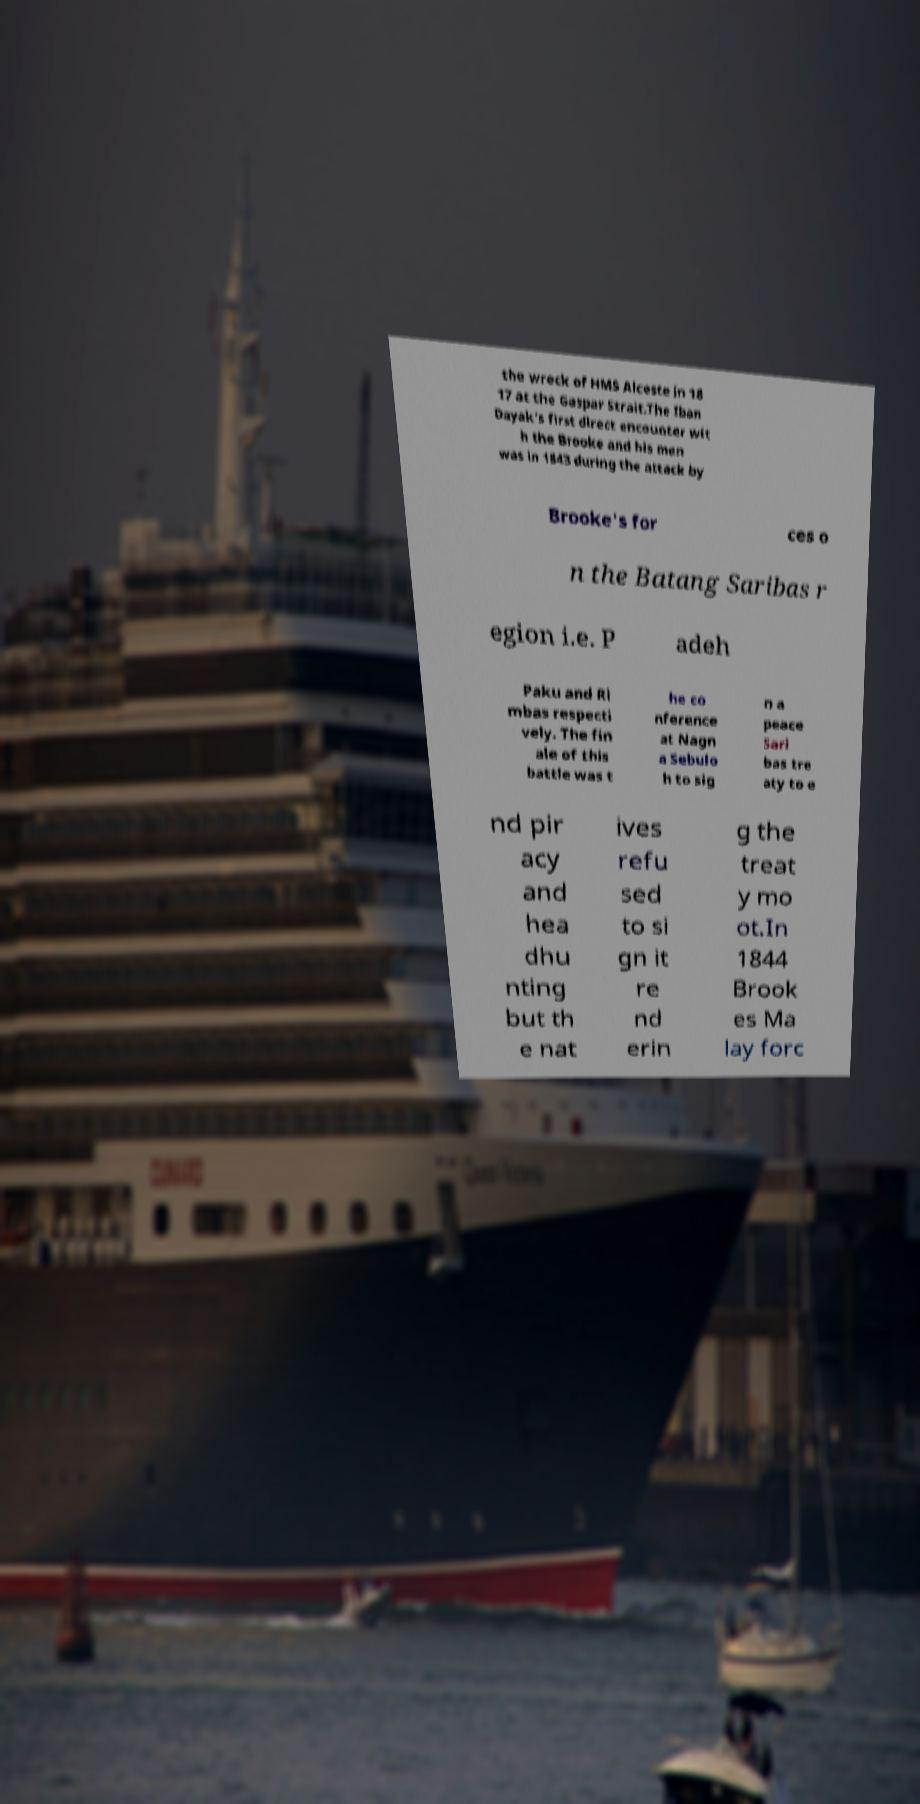Please read and relay the text visible in this image. What does it say? the wreck of HMS Alceste in 18 17 at the Gaspar Strait.The Iban Dayak's first direct encounter wit h the Brooke and his men was in 1843 during the attack by Brooke's for ces o n the Batang Saribas r egion i.e. P adeh Paku and Ri mbas respecti vely. The fin ale of this battle was t he co nference at Nagn a Sebulo h to sig n a peace Sari bas tre aty to e nd pir acy and hea dhu nting but th e nat ives refu sed to si gn it re nd erin g the treat y mo ot.In 1844 Brook es Ma lay forc 